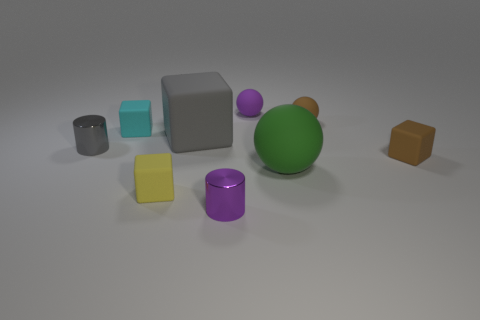Subtract all red blocks. Subtract all purple cylinders. How many blocks are left? 4 Add 1 blocks. How many objects exist? 10 Subtract all cylinders. How many objects are left? 7 Add 6 gray rubber things. How many gray rubber things exist? 7 Subtract 0 red cylinders. How many objects are left? 9 Subtract all big yellow matte things. Subtract all tiny brown rubber spheres. How many objects are left? 8 Add 1 brown rubber spheres. How many brown rubber spheres are left? 2 